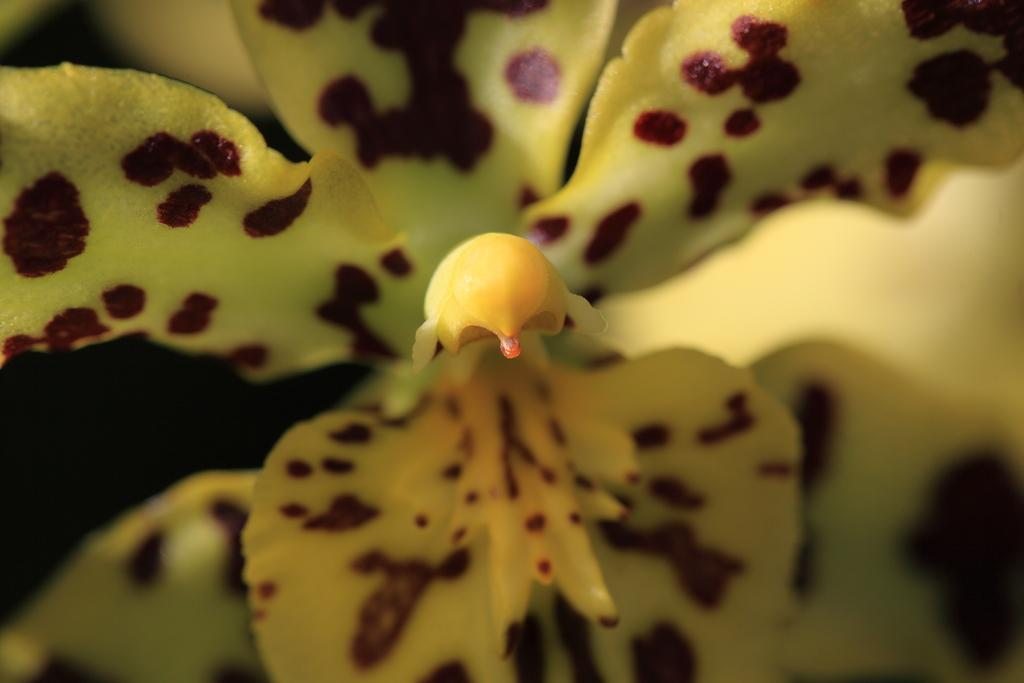What is the main subject in the foreground of the image? There is a flower in the foreground of the image. Can you describe the specific part of the flower that is in the middle? The stigma of the flower is in the middle. Is there a mask covering the flower in the image? No, there is no mask present in the image. Can you describe the weather conditions in the image? The provided facts do not mention any weather conditions, so it cannot be determined from the image. 